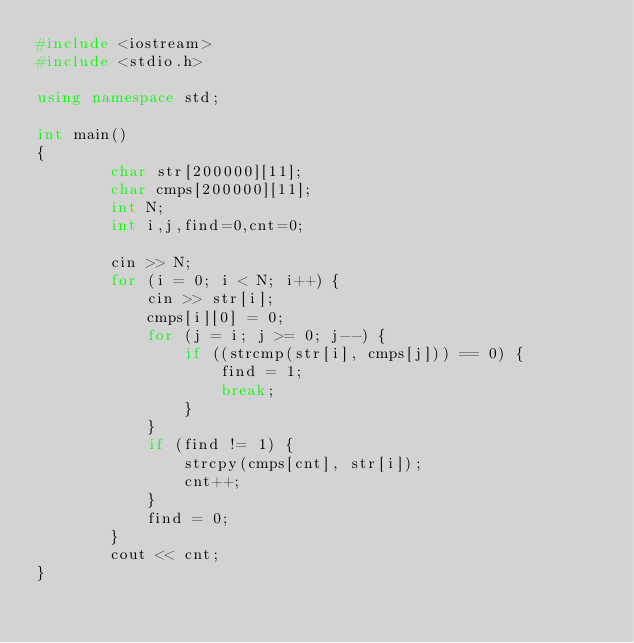<code> <loc_0><loc_0><loc_500><loc_500><_C++_>#include <iostream>
#include <stdio.h>

using namespace std;

int main()
{
		char str[200000][11];
		char cmps[200000][11];
		int N;
		int i,j,find=0,cnt=0;

		cin >> N;
		for (i = 0; i < N; i++) {
			cin >> str[i];
			cmps[i][0] = 0;
			for (j = i; j >= 0; j--) {
				if ((strcmp(str[i], cmps[j])) == 0) {
					find = 1;
					break;
				}
			}
			if (find != 1) {
				strcpy(cmps[cnt], str[i]);
				cnt++;
			}
			find = 0;
		}
		cout << cnt;
}</code> 